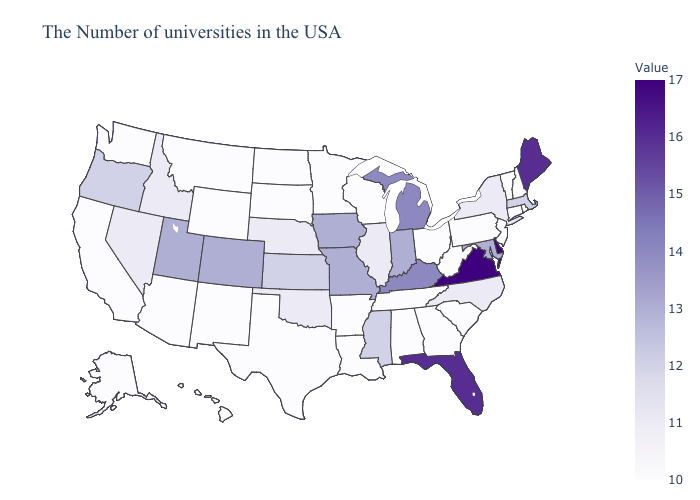Among the states that border Tennessee , which have the lowest value?
Quick response, please. Georgia, Alabama, Arkansas. Among the states that border Kansas , does Oklahoma have the lowest value?
Keep it brief. Yes. 